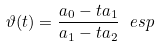<formula> <loc_0><loc_0><loc_500><loc_500>\vartheta ( t ) = \frac { a _ { 0 } - t a _ { 1 } } { a _ { 1 } - t a _ { 2 } } \ e s p</formula> 